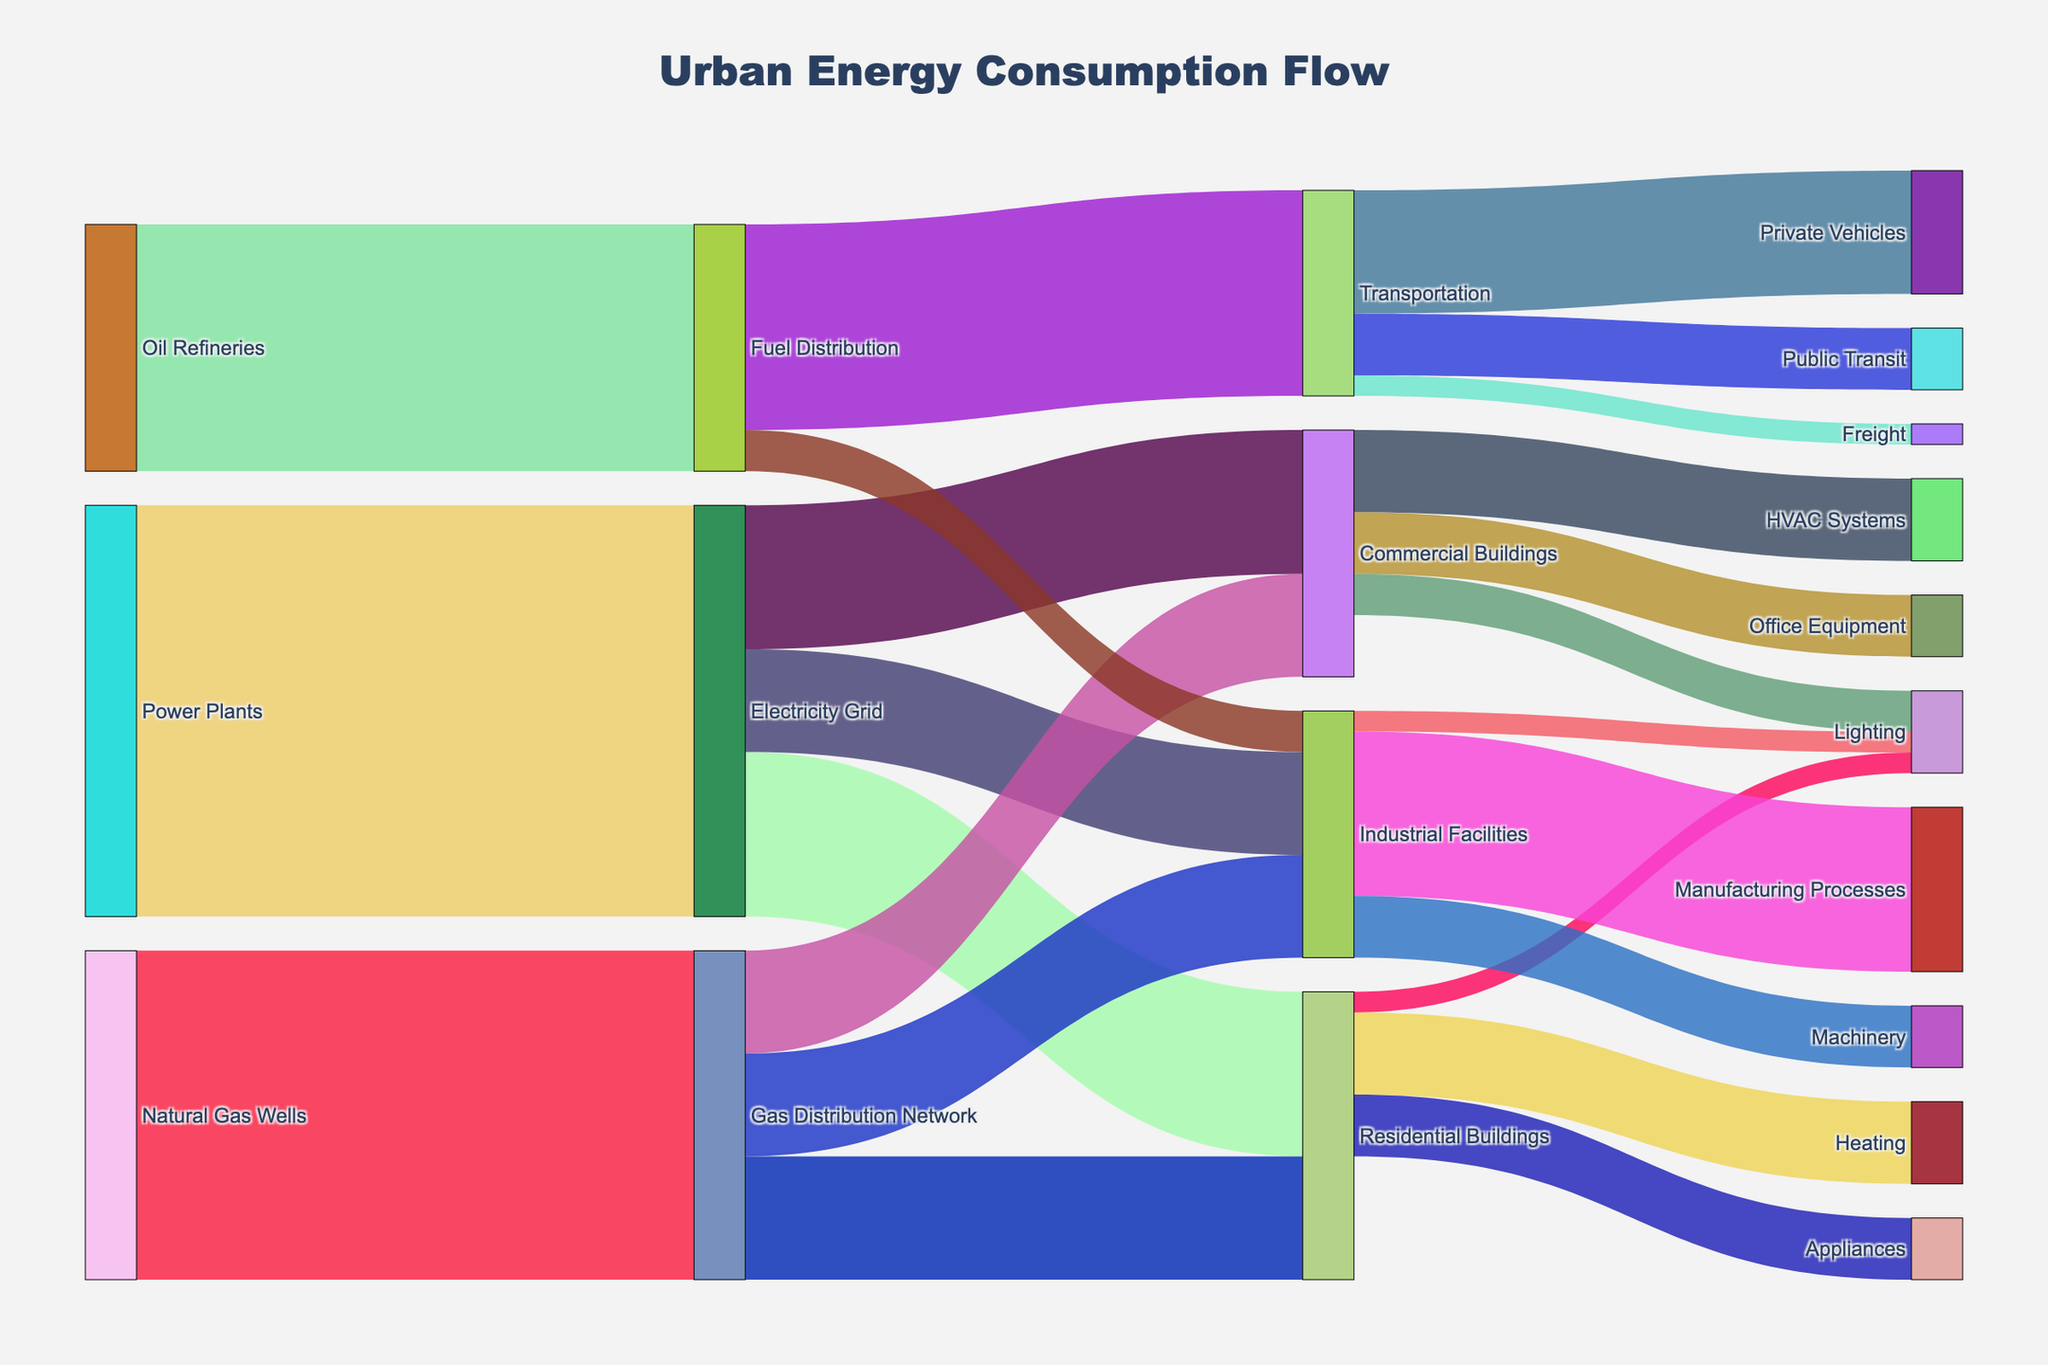What is the total energy supplied to urban areas from Power Plants, Natural Gas Wells, and Oil Refineries? First, identify the values given for 'Power Plants', 'Natural Gas Wells', and 'Oil Refineries'. From the figure: Power Plants → Electricity Grid = 1000, Natural Gas Wells → Gas Distribution Network = 800, Oil Refineries → Fuel Distribution = 600. Summing these: 1000 + 800 + 600 = 2400.
Answer: 2400 Which end-use sector receives the most energy from the Electricity Grid? Observe the flows from the 'Electricity Grid' to the end-use sectors. The values are Residential Buildings = 400, Commercial Buildings = 350, Industrial Facilities = 250. The largest value is for Residential Buildings.
Answer: Residential Buildings How much energy is used by Commercial Buildings for HVAC Systems compared to Office Equipment? Identify the values for energy flowing to the 'HVAC Systems' and 'Office Equipment' from 'Commercial Buildings'. The values are HVAC Systems = 200, Office Equipment = 150. Therefore, HVAC Systems use more energy.
Answer: HVAC Systems What percentage of energy from Power Plants is consumed by Industrial Facilities through the Electricity Grid? The energy flow from Power Plants to Electricity Grid is 1000. The flow from Electricity Grid to Industrial Facilities is 250. Calculate the percentage: (250 / 1000) * 100 = 25%.
Answer: 25% How much energy is distributed to Residential Buildings as a total from all sources? Identify the flows to Residential Buildings: Electricity Grid = 400, Gas Distribution Network = 300. Sum these: 400 + 300 = 700.
Answer: 700 Is the energy used by Transportation greater than that used by Industrial Facilities from the Fuel Distribution network? Compare the values from Fuel Distribution to Transportation = 500, and to Industrial Facilities = 100. Transportation receives more energy.
Answer: Yes What is the total energy used by all Lighting applications in the figure? Identify the values for lighting: Residential Buildings → Lighting = 50, Commercial Buildings → Lighting = 100, Industrial Facilities → Lighting = 50. Sum these: 50 + 100 + 50 = 200.
Answer: 200 Which node has the highest energy inflow, and how much is it? Look for the node with the highest combined inflow. Comparing significant nodes: Residential Buildings = 400 (Electricity Grid) + 300 (Gas Distribution Network) = 700, Transportation = 500 (Fuel Distribution). The highest inflow is Residential Buildings with 700.
Answer: Residential Buildings, 700 What is the total amount of energy consumed by Industrial Facilities across all sources and uses? Summing the inflows and outflows: Inflow - Electricity Grid = 250, Gas Distribution Network = 250, Fuel Distribution = 100; Outflow - Manufacturing Processes = 400, Machinery = 150, Lighting = 50. Total= 250 + 250 + 100 = 600, Total = 400 + 150 + 50 = 600. Consistency confirms it's 600.
Answer: 600 